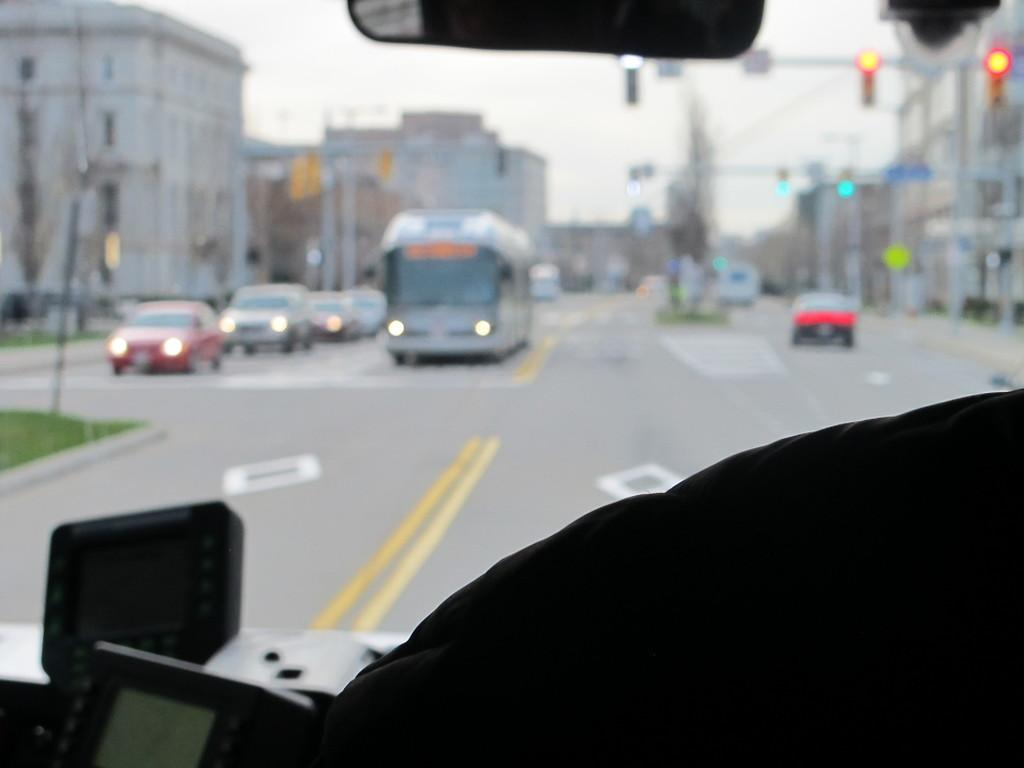What can be seen on the road in the image? There are fleets of vehicles on the road in the image. What structures are visible in the image? Light poles, sign boards, buildings, and a fence are visible in the image. What type of vegetation is present in the image? Grass and trees are present in the image. What architectural features can be seen in the image? Windows are visible in the image. What part of the natural environment is visible in the image? The sky is visible in the image. Where is the faucet located in the image? There is no faucet present in the image. What day of the week is depicted in the image? The image does not show a calendar or any indication of the day of the week. What time of day is it in the image? The image does not provide any information about the time of day, such as shadows or specific lighting. 